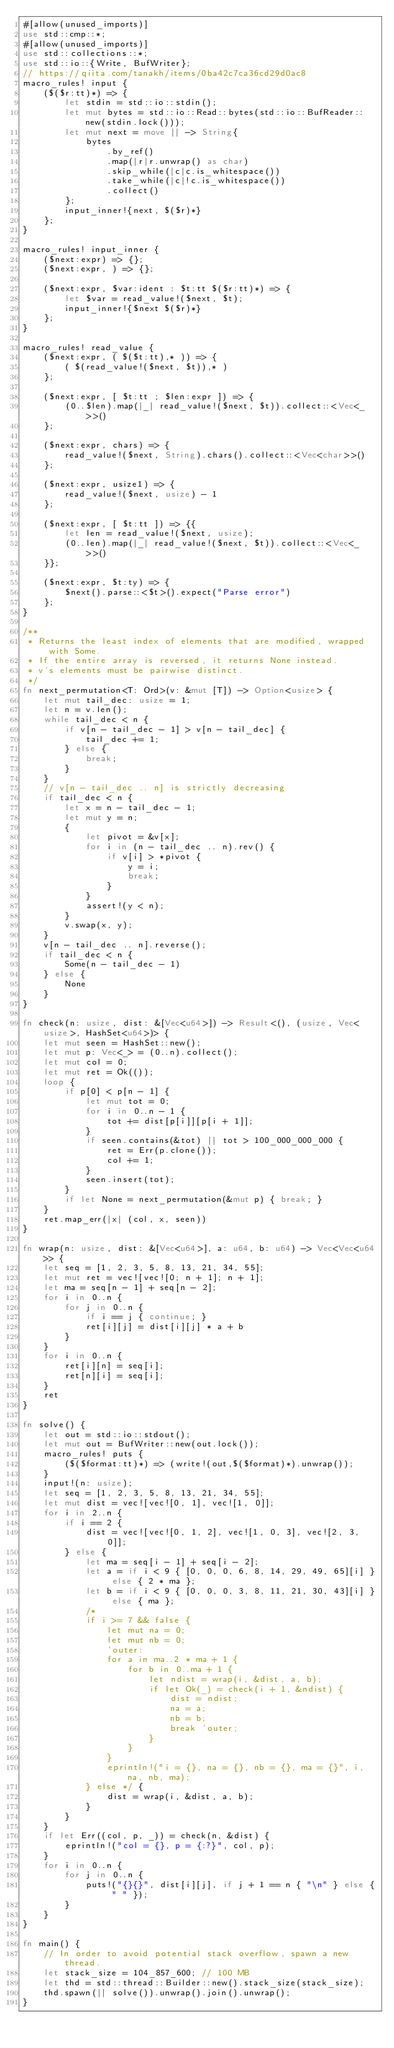Convert code to text. <code><loc_0><loc_0><loc_500><loc_500><_Rust_>#[allow(unused_imports)]
use std::cmp::*;
#[allow(unused_imports)]
use std::collections::*;
use std::io::{Write, BufWriter};
// https://qiita.com/tanakh/items/0ba42c7ca36cd29d0ac8
macro_rules! input {
    ($($r:tt)*) => {
        let stdin = std::io::stdin();
        let mut bytes = std::io::Read::bytes(std::io::BufReader::new(stdin.lock()));
        let mut next = move || -> String{
            bytes
                .by_ref()
                .map(|r|r.unwrap() as char)
                .skip_while(|c|c.is_whitespace())
                .take_while(|c|!c.is_whitespace())
                .collect()
        };
        input_inner!{next, $($r)*}
    };
}

macro_rules! input_inner {
    ($next:expr) => {};
    ($next:expr, ) => {};

    ($next:expr, $var:ident : $t:tt $($r:tt)*) => {
        let $var = read_value!($next, $t);
        input_inner!{$next $($r)*}
    };
}

macro_rules! read_value {
    ($next:expr, ( $($t:tt),* )) => {
        ( $(read_value!($next, $t)),* )
    };

    ($next:expr, [ $t:tt ; $len:expr ]) => {
        (0..$len).map(|_| read_value!($next, $t)).collect::<Vec<_>>()
    };

    ($next:expr, chars) => {
        read_value!($next, String).chars().collect::<Vec<char>>()
    };

    ($next:expr, usize1) => {
        read_value!($next, usize) - 1
    };

    ($next:expr, [ $t:tt ]) => {{
        let len = read_value!($next, usize);
        (0..len).map(|_| read_value!($next, $t)).collect::<Vec<_>>()
    }};

    ($next:expr, $t:ty) => {
        $next().parse::<$t>().expect("Parse error")
    };
}

/**
 * Returns the least index of elements that are modified, wrapped with Some.
 * If the entire array is reversed, it returns None instead.
 * v's elements must be pairwise distinct.
 */
fn next_permutation<T: Ord>(v: &mut [T]) -> Option<usize> {
    let mut tail_dec: usize = 1;
    let n = v.len();
    while tail_dec < n {
        if v[n - tail_dec - 1] > v[n - tail_dec] {
            tail_dec += 1;
        } else {
            break;
        }
    }
    // v[n - tail_dec .. n] is strictly decreasing
    if tail_dec < n {
        let x = n - tail_dec - 1;
        let mut y = n;
        {
            let pivot = &v[x];
            for i in (n - tail_dec .. n).rev() {
                if v[i] > *pivot {
                    y = i;
                    break;
                }
            }
            assert!(y < n);
        }
        v.swap(x, y);
    }
    v[n - tail_dec .. n].reverse();
    if tail_dec < n {
        Some(n - tail_dec - 1)
    } else {
        None
    }
}

fn check(n: usize, dist: &[Vec<u64>]) -> Result<(), (usize, Vec<usize>, HashSet<u64>)> {
    let mut seen = HashSet::new();
    let mut p: Vec<_> = (0..n).collect();
    let mut col = 0;
    let mut ret = Ok(());
    loop {
        if p[0] < p[n - 1] {
            let mut tot = 0;
            for i in 0..n - 1 {
                tot += dist[p[i]][p[i + 1]];
            }
            if seen.contains(&tot) || tot > 100_000_000_000 {
                ret = Err(p.clone());
                col += 1;
            }
            seen.insert(tot);
        }
        if let None = next_permutation(&mut p) { break; }
    }
    ret.map_err(|x| (col, x, seen))
}

fn wrap(n: usize, dist: &[Vec<u64>], a: u64, b: u64) -> Vec<Vec<u64>> {
    let seq = [1, 2, 3, 5, 8, 13, 21, 34, 55];
    let mut ret = vec![vec![0; n + 1]; n + 1];
    let ma = seq[n - 1] + seq[n - 2];
    for i in 0..n {
        for j in 0..n {
            if i == j { continue; }
            ret[i][j] = dist[i][j] * a + b
        }
    }
    for i in 0..n {
        ret[i][n] = seq[i];
        ret[n][i] = seq[i];
    }
    ret
}

fn solve() {
    let out = std::io::stdout();
    let mut out = BufWriter::new(out.lock());
    macro_rules! puts {
        ($($format:tt)*) => (write!(out,$($format)*).unwrap());
    }
    input!(n: usize);
    let seq = [1, 2, 3, 5, 8, 13, 21, 34, 55];
    let mut dist = vec![vec![0, 1], vec![1, 0]];
    for i in 2..n {
        if i == 2 {
            dist = vec![vec![0, 1, 2], vec![1, 0, 3], vec![2, 3, 0]];
        } else {
            let ma = seq[i - 1] + seq[i - 2];
            let a = if i < 9 { [0, 0, 0, 6, 8, 14, 29, 49, 65][i] } else { 2 * ma };
            let b = if i < 9 { [0, 0, 0, 3, 8, 11, 21, 30, 43][i] } else { ma };
            /*
            if i >= 7 && false {
                let mut na = 0;
                let mut nb = 0;
                'outer:
                for a in ma..2 * ma + 1 {
                    for b in 0..ma + 1 {
                        let ndist = wrap(i, &dist, a, b);
                        if let Ok(_) = check(i + 1, &ndist) {
                            dist = ndist;
                            na = a;
                            nb = b;
                            break 'outer;
                        }
                    }
                }
                eprintln!("i = {}, na = {}, nb = {}, ma = {}", i, na, nb, ma);
            } else */ {
                dist = wrap(i, &dist, a, b);
            }
        }
    }
    if let Err((col, p, _)) = check(n, &dist) {
        eprintln!("col = {}, p = {:?}", col, p);
    }
    for i in 0..n {
        for j in 0..n {
            puts!("{}{}", dist[i][j], if j + 1 == n { "\n" } else { " " });
        }
    }
}

fn main() {
    // In order to avoid potential stack overflow, spawn a new thread.
    let stack_size = 104_857_600; // 100 MB
    let thd = std::thread::Builder::new().stack_size(stack_size);
    thd.spawn(|| solve()).unwrap().join().unwrap();
}
</code> 